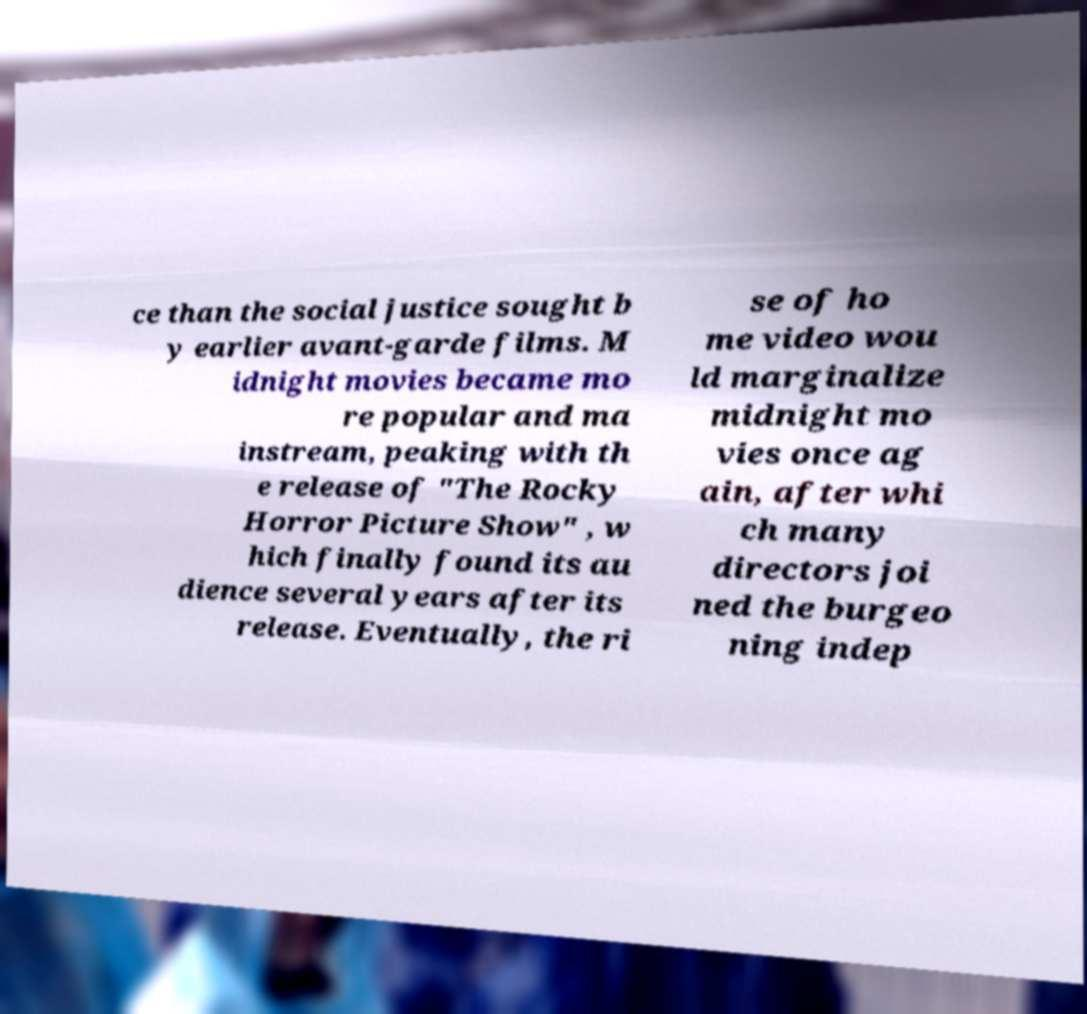There's text embedded in this image that I need extracted. Can you transcribe it verbatim? ce than the social justice sought b y earlier avant-garde films. M idnight movies became mo re popular and ma instream, peaking with th e release of "The Rocky Horror Picture Show" , w hich finally found its au dience several years after its release. Eventually, the ri se of ho me video wou ld marginalize midnight mo vies once ag ain, after whi ch many directors joi ned the burgeo ning indep 